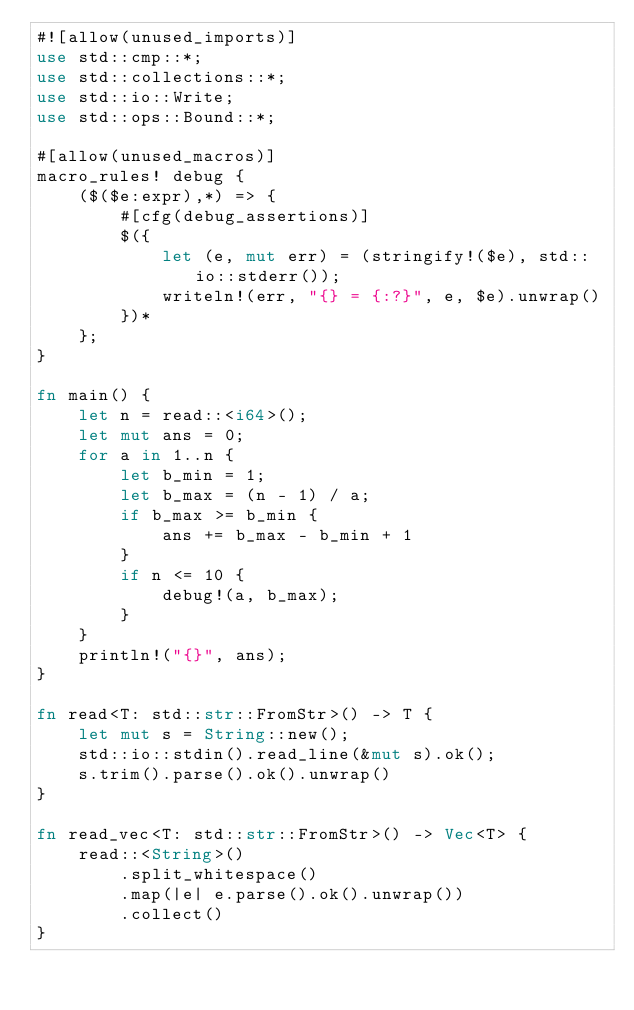Convert code to text. <code><loc_0><loc_0><loc_500><loc_500><_Rust_>#![allow(unused_imports)]
use std::cmp::*;
use std::collections::*;
use std::io::Write;
use std::ops::Bound::*;

#[allow(unused_macros)]
macro_rules! debug {
    ($($e:expr),*) => {
        #[cfg(debug_assertions)]
        $({
            let (e, mut err) = (stringify!($e), std::io::stderr());
            writeln!(err, "{} = {:?}", e, $e).unwrap()
        })*
    };
}

fn main() {
    let n = read::<i64>();
    let mut ans = 0;
    for a in 1..n {
        let b_min = 1;
        let b_max = (n - 1) / a;
        if b_max >= b_min {
            ans += b_max - b_min + 1
        }
        if n <= 10 {
            debug!(a, b_max);
        }
    }
    println!("{}", ans);
}

fn read<T: std::str::FromStr>() -> T {
    let mut s = String::new();
    std::io::stdin().read_line(&mut s).ok();
    s.trim().parse().ok().unwrap()
}

fn read_vec<T: std::str::FromStr>() -> Vec<T> {
    read::<String>()
        .split_whitespace()
        .map(|e| e.parse().ok().unwrap())
        .collect()
}
</code> 